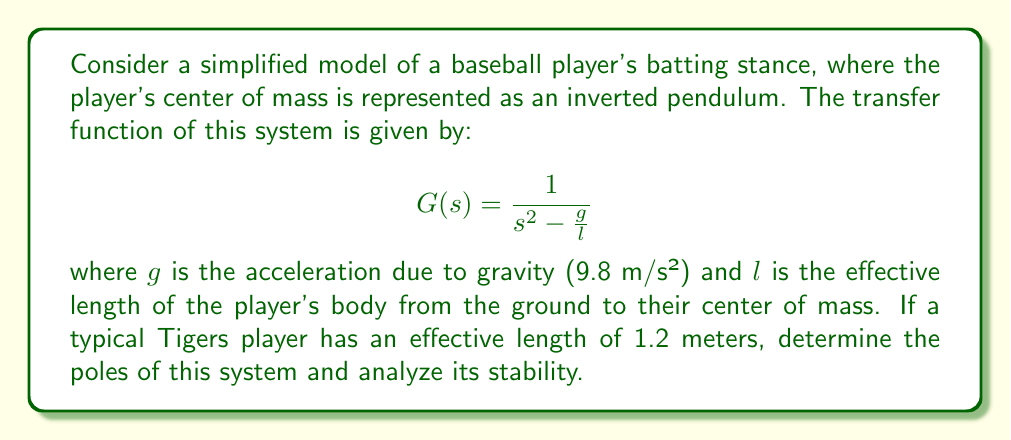Help me with this question. To analyze the stability of this system, we need to follow these steps:

1) First, recall that the poles of a system are the roots of the denominator of the transfer function when set equal to zero.

2) In this case, we need to solve the equation:
   $$s^2 - \frac{g}{l} = 0$$

3) Substituting the given values:
   $$s^2 - \frac{9.8}{1.2} = 0$$
   $$s^2 - 8.167 = 0$$

4) This is a quadratic equation. We can solve it by taking the square root of both sides:
   $$s = \pm \sqrt{8.167}$$

5) Calculating this:
   $$s = \pm 2.858$$

6) Therefore, the poles of the system are at $s = 2.858$ and $s = -2.858$.

7) For a system to be stable, all poles must be in the left half of the s-plane (i.e., have negative real parts). In this case, we have one pole in the right half-plane (positive) and one in the left half-plane (negative).

8) This indicates that the system is unstable. Physically, this makes sense as an inverted pendulum (like a baseball player in their stance) is inherently unstable and will fall over without active control.
Answer: The poles of the system are at $s = 2.858$ and $s = -2.858$. The system is unstable because it has a pole in the right half of the s-plane. 